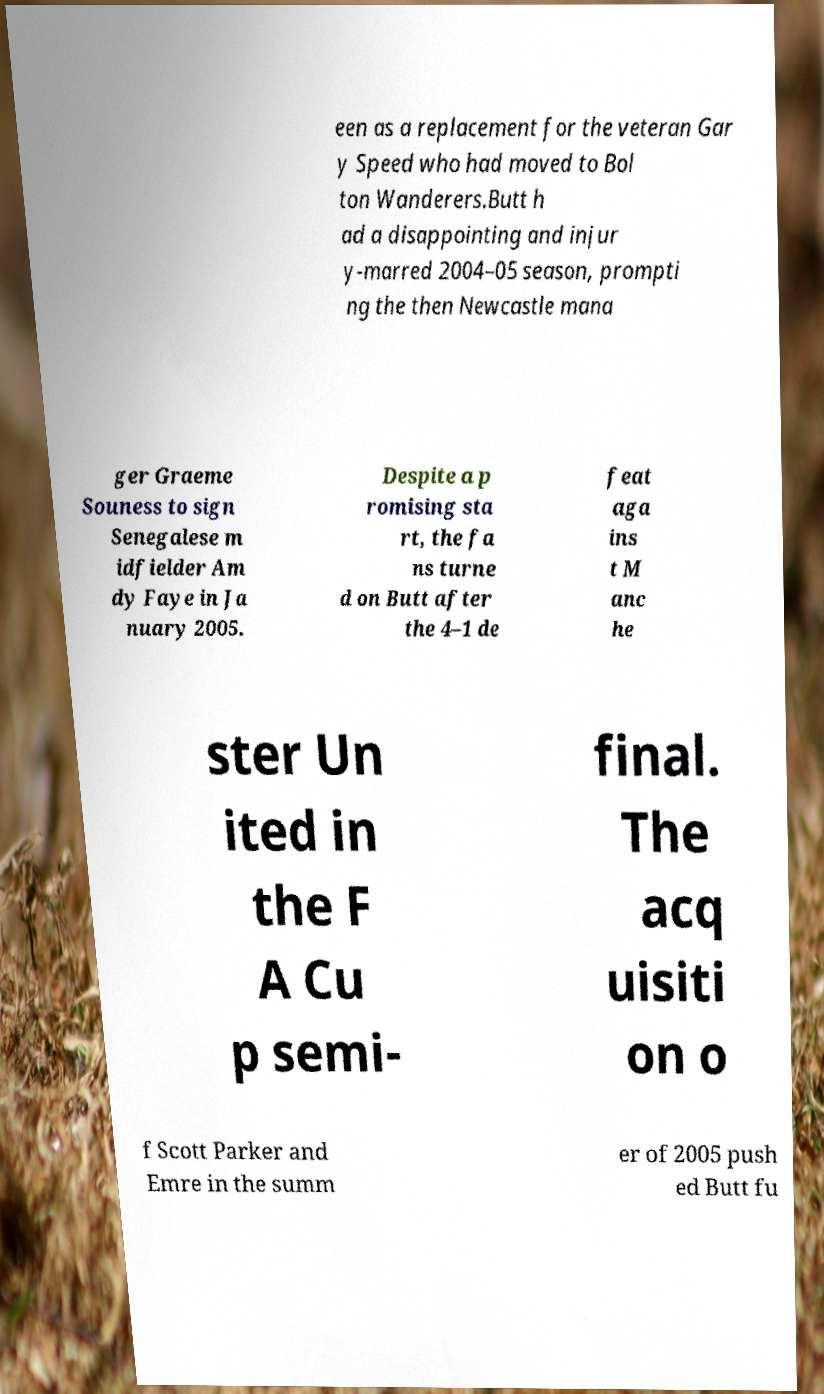Can you read and provide the text displayed in the image?This photo seems to have some interesting text. Can you extract and type it out for me? een as a replacement for the veteran Gar y Speed who had moved to Bol ton Wanderers.Butt h ad a disappointing and injur y-marred 2004–05 season, prompti ng the then Newcastle mana ger Graeme Souness to sign Senegalese m idfielder Am dy Faye in Ja nuary 2005. Despite a p romising sta rt, the fa ns turne d on Butt after the 4–1 de feat aga ins t M anc he ster Un ited in the F A Cu p semi- final. The acq uisiti on o f Scott Parker and Emre in the summ er of 2005 push ed Butt fu 